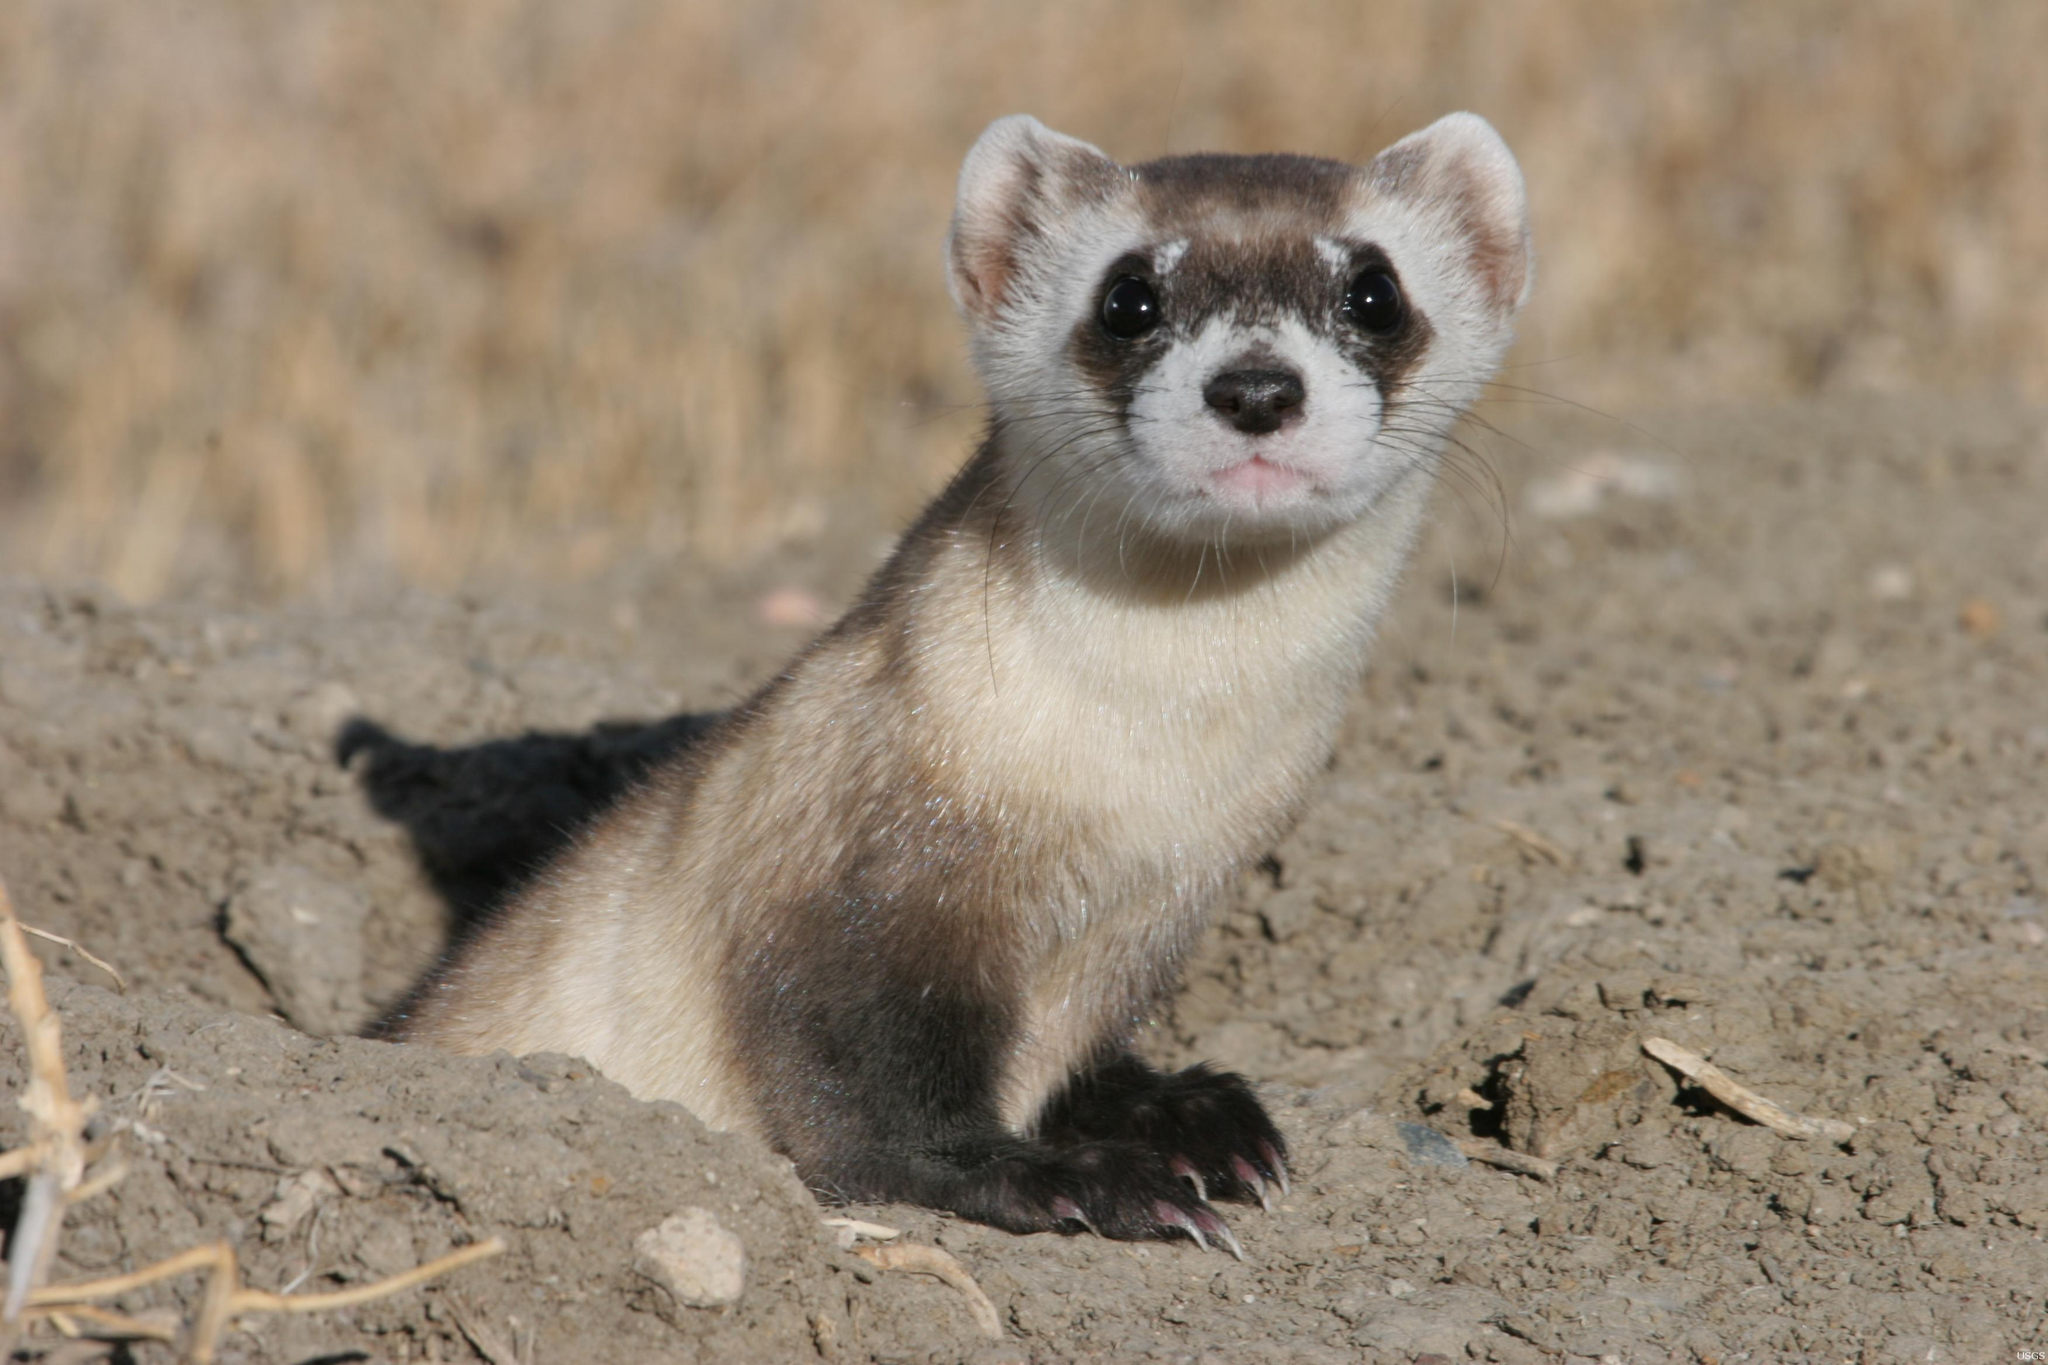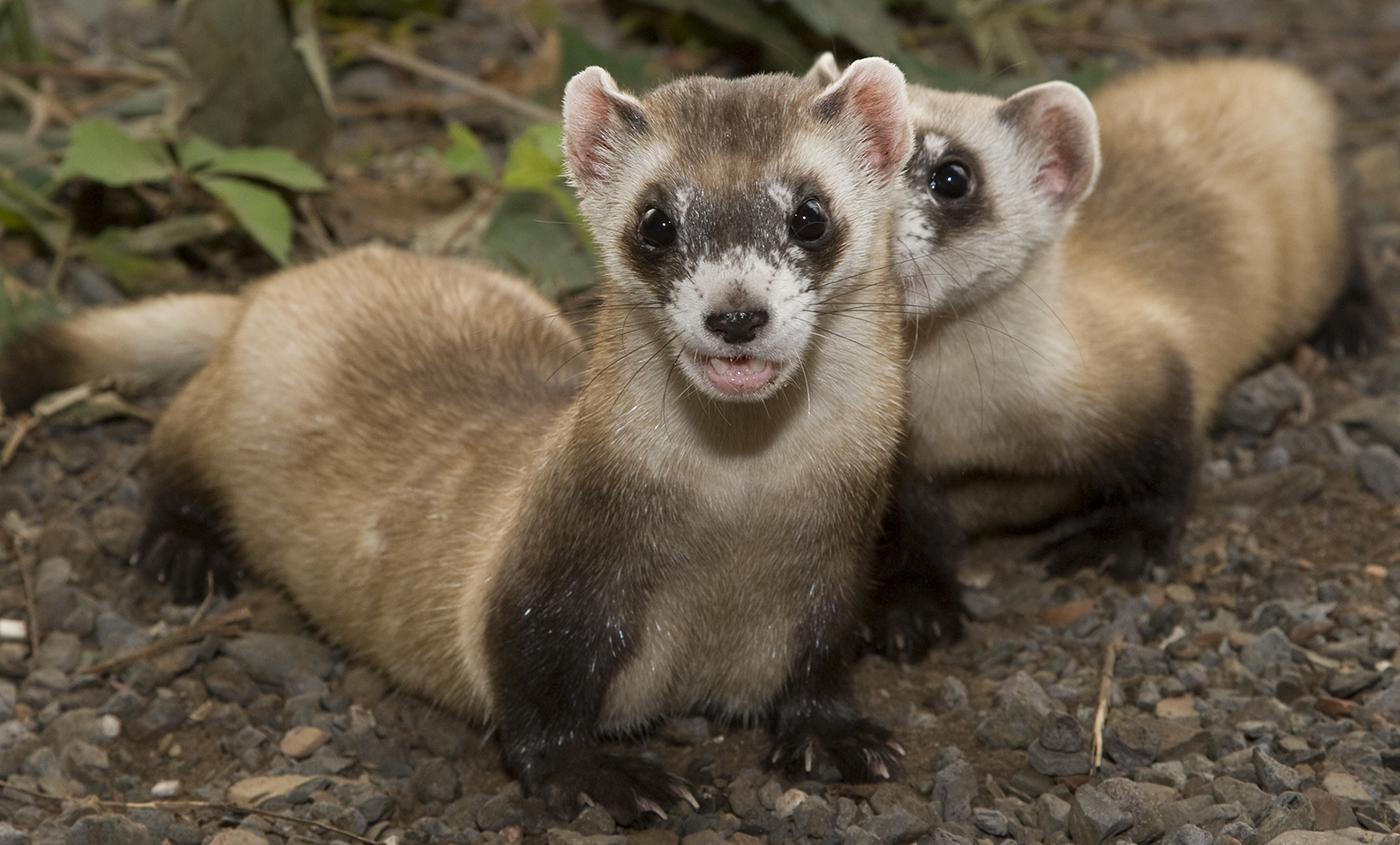The first image is the image on the left, the second image is the image on the right. Evaluate the accuracy of this statement regarding the images: "The images contain a total of four ferrets.". Is it true? Answer yes or no. No. The first image is the image on the left, the second image is the image on the right. Given the left and right images, does the statement "There are at least two animals in the image on the right." hold true? Answer yes or no. Yes. The first image is the image on the left, the second image is the image on the right. Examine the images to the left and right. Is the description "An image shows exactly one ferret partly emerged from a hole in the ground, with no manmade material visible." accurate? Answer yes or no. Yes. The first image is the image on the left, the second image is the image on the right. Evaluate the accuracy of this statement regarding the images: "There are two animals in total.". Is it true? Answer yes or no. No. The first image is the image on the left, the second image is the image on the right. Given the left and right images, does the statement "There are no more than three ferrets" hold true? Answer yes or no. Yes. 